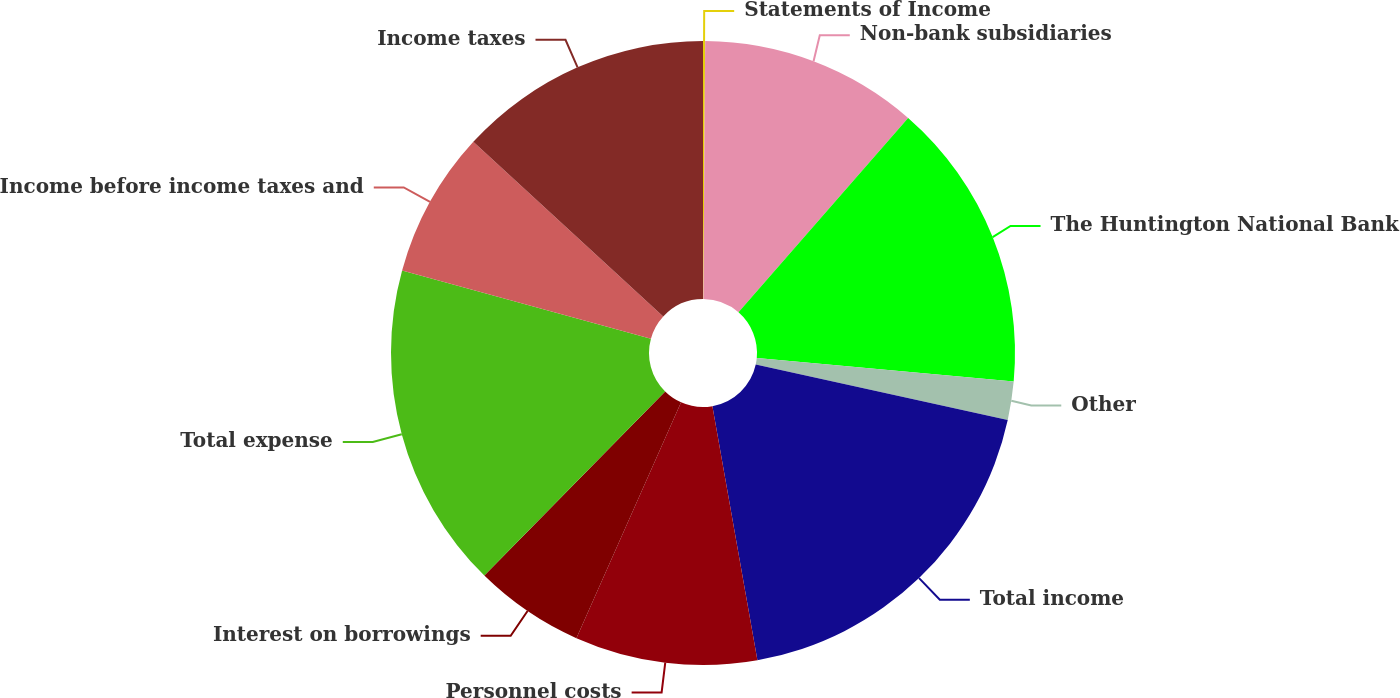<chart> <loc_0><loc_0><loc_500><loc_500><pie_chart><fcel>Statements of Income<fcel>Non-bank subsidiaries<fcel>The Huntington National Bank<fcel>Other<fcel>Total income<fcel>Personnel costs<fcel>Interest on borrowings<fcel>Total expense<fcel>Income before income taxes and<fcel>Income taxes<nl><fcel>0.11%<fcel>11.31%<fcel>15.04%<fcel>1.98%<fcel>18.77%<fcel>9.44%<fcel>5.71%<fcel>16.9%<fcel>7.57%<fcel>13.17%<nl></chart> 